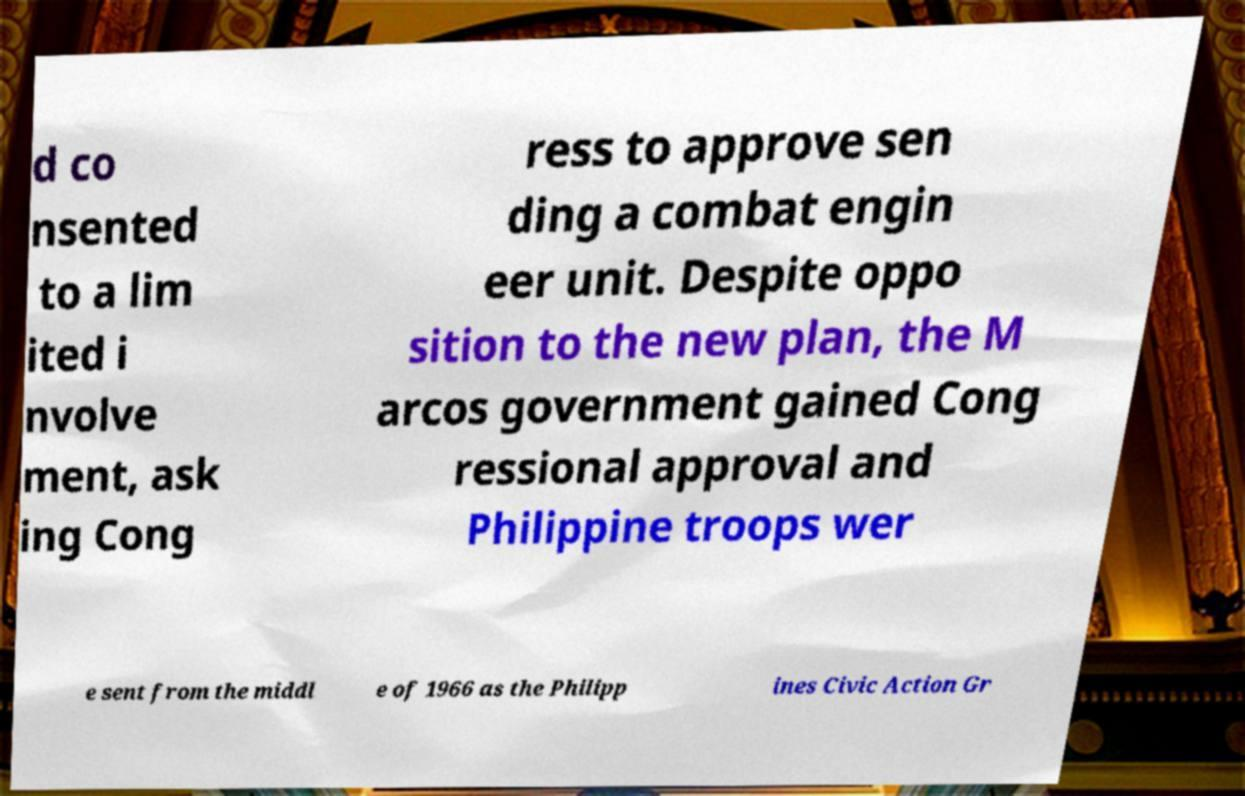Can you read and provide the text displayed in the image?This photo seems to have some interesting text. Can you extract and type it out for me? d co nsented to a lim ited i nvolve ment, ask ing Cong ress to approve sen ding a combat engin eer unit. Despite oppo sition to the new plan, the M arcos government gained Cong ressional approval and Philippine troops wer e sent from the middl e of 1966 as the Philipp ines Civic Action Gr 